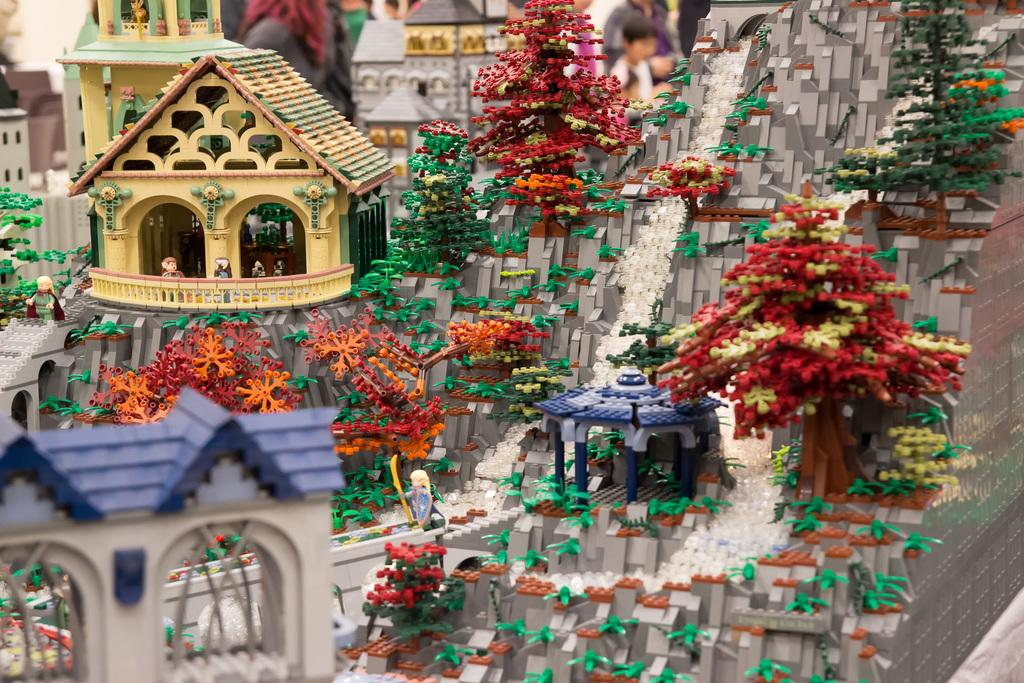What is the main subject of the image? There is a doll house in the image. What can be seen inside the doll house? There are dolls inside the doll house. What is located on the right side of the image? There is a group of trees and a group of people on the right side of the image. What type of plants are being tested in the image? There is no indication of any plants or testing in the image. 